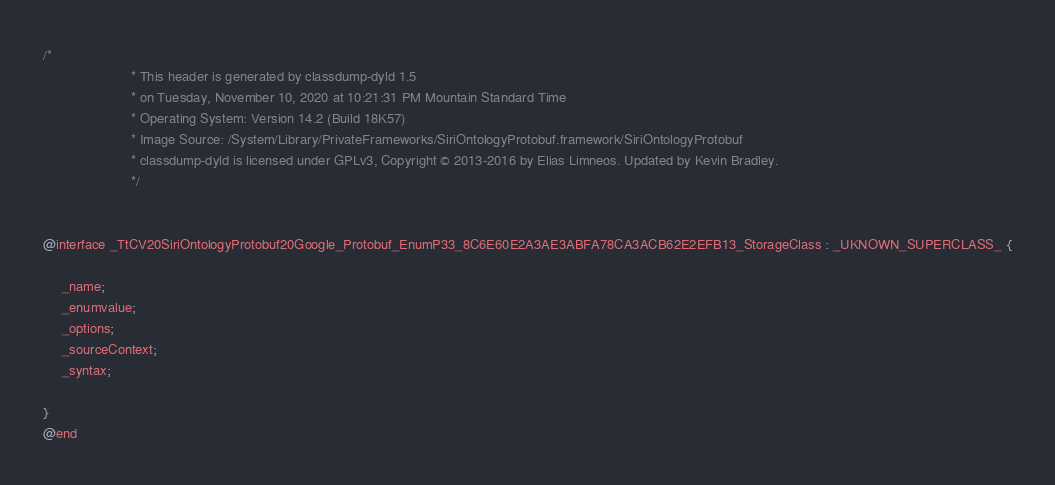Convert code to text. <code><loc_0><loc_0><loc_500><loc_500><_C_>/*
                       * This header is generated by classdump-dyld 1.5
                       * on Tuesday, November 10, 2020 at 10:21:31 PM Mountain Standard Time
                       * Operating System: Version 14.2 (Build 18K57)
                       * Image Source: /System/Library/PrivateFrameworks/SiriOntologyProtobuf.framework/SiriOntologyProtobuf
                       * classdump-dyld is licensed under GPLv3, Copyright © 2013-2016 by Elias Limneos. Updated by Kevin Bradley.
                       */


@interface _TtCV20SiriOntologyProtobuf20Google_Protobuf_EnumP33_8C6E60E2A3AE3ABFA78CA3ACB62E2EFB13_StorageClass : _UKNOWN_SUPERCLASS_ {

	 _name;
	 _enumvalue;
	 _options;
	 _sourceContext;
	 _syntax;

}
@end

</code> 